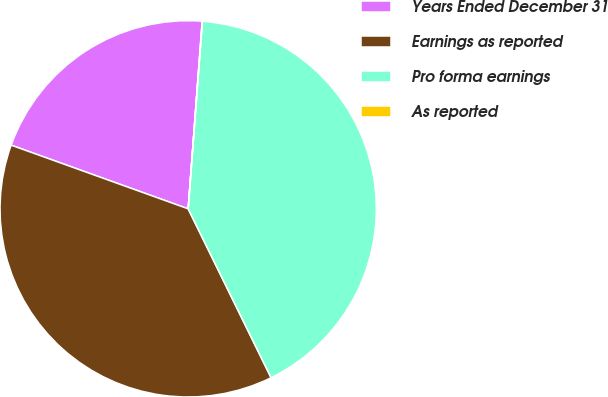<chart> <loc_0><loc_0><loc_500><loc_500><pie_chart><fcel>Years Ended December 31<fcel>Earnings as reported<fcel>Pro forma earnings<fcel>As reported<nl><fcel>20.69%<fcel>37.76%<fcel>41.53%<fcel>0.02%<nl></chart> 